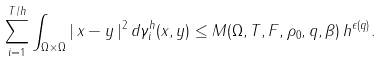Convert formula to latex. <formula><loc_0><loc_0><loc_500><loc_500>\sum _ { i = 1 } ^ { T / h } \int _ { \Omega \times \Omega } | \, x - y \, | ^ { 2 } \, d \gamma _ { i } ^ { h } ( x , y ) \leq M ( \Omega , T , F , \rho _ { 0 } , q , \beta ) \, h ^ { \epsilon ( q ) } .</formula> 